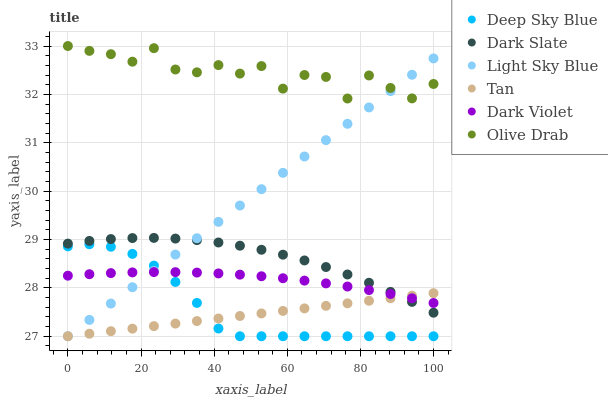Does Tan have the minimum area under the curve?
Answer yes or no. Yes. Does Olive Drab have the maximum area under the curve?
Answer yes or no. Yes. Does Dark Slate have the minimum area under the curve?
Answer yes or no. No. Does Dark Slate have the maximum area under the curve?
Answer yes or no. No. Is Tan the smoothest?
Answer yes or no. Yes. Is Olive Drab the roughest?
Answer yes or no. Yes. Is Dark Slate the smoothest?
Answer yes or no. No. Is Dark Slate the roughest?
Answer yes or no. No. Does Light Sky Blue have the lowest value?
Answer yes or no. Yes. Does Dark Slate have the lowest value?
Answer yes or no. No. Does Olive Drab have the highest value?
Answer yes or no. Yes. Does Dark Slate have the highest value?
Answer yes or no. No. Is Dark Slate less than Olive Drab?
Answer yes or no. Yes. Is Olive Drab greater than Tan?
Answer yes or no. Yes. Does Deep Sky Blue intersect Dark Violet?
Answer yes or no. Yes. Is Deep Sky Blue less than Dark Violet?
Answer yes or no. No. Is Deep Sky Blue greater than Dark Violet?
Answer yes or no. No. Does Dark Slate intersect Olive Drab?
Answer yes or no. No. 